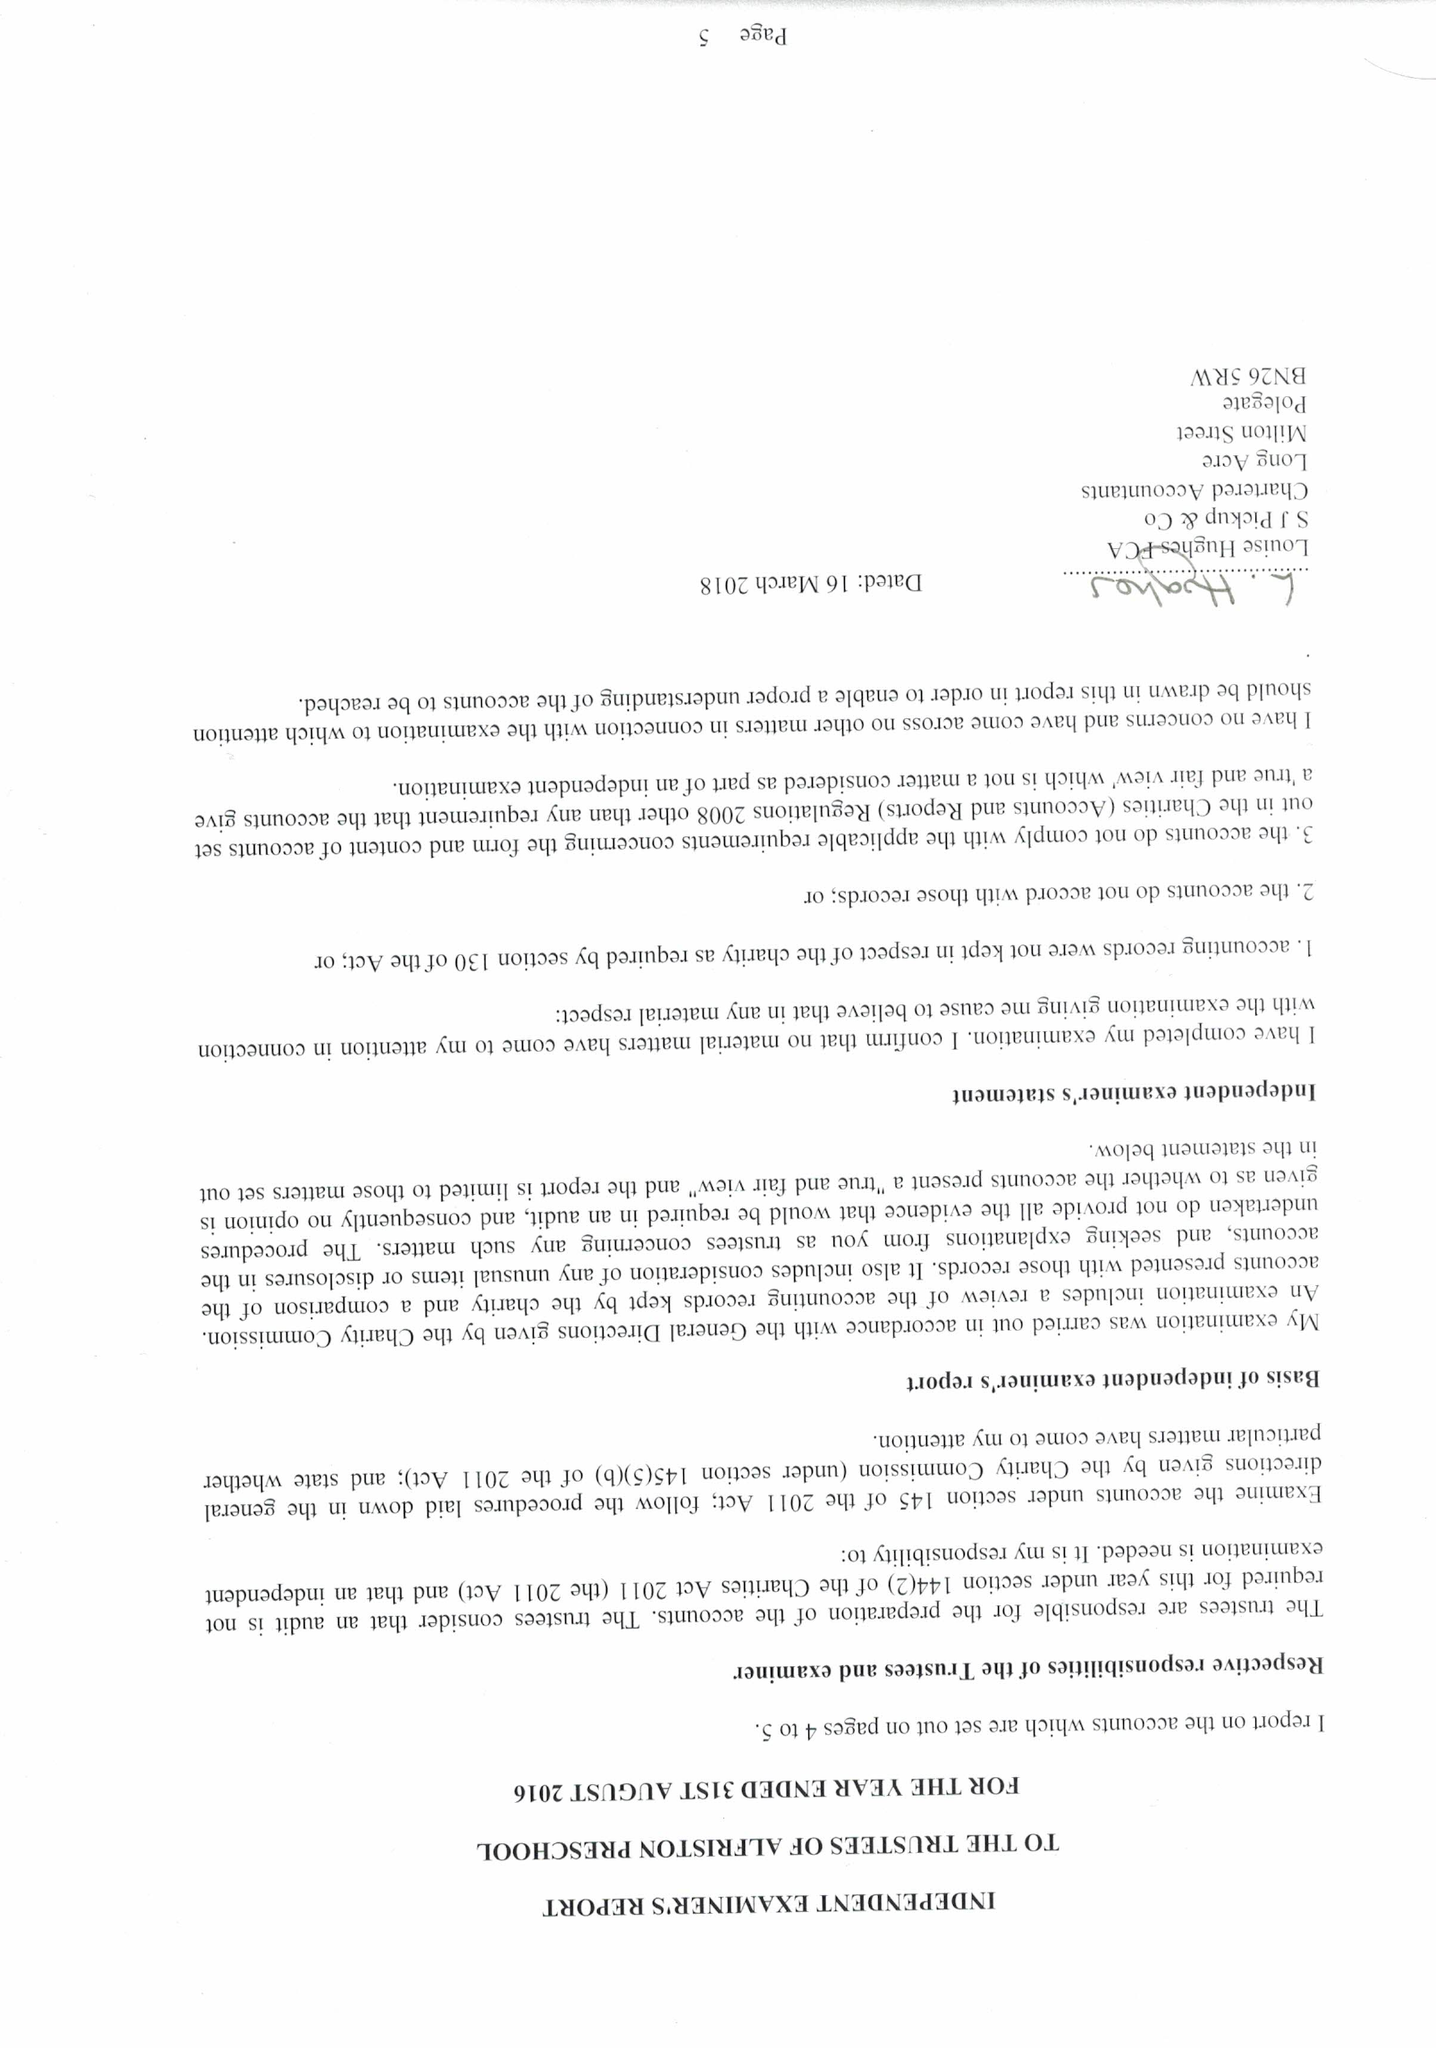What is the value for the report_date?
Answer the question using a single word or phrase. 2017-08-31 